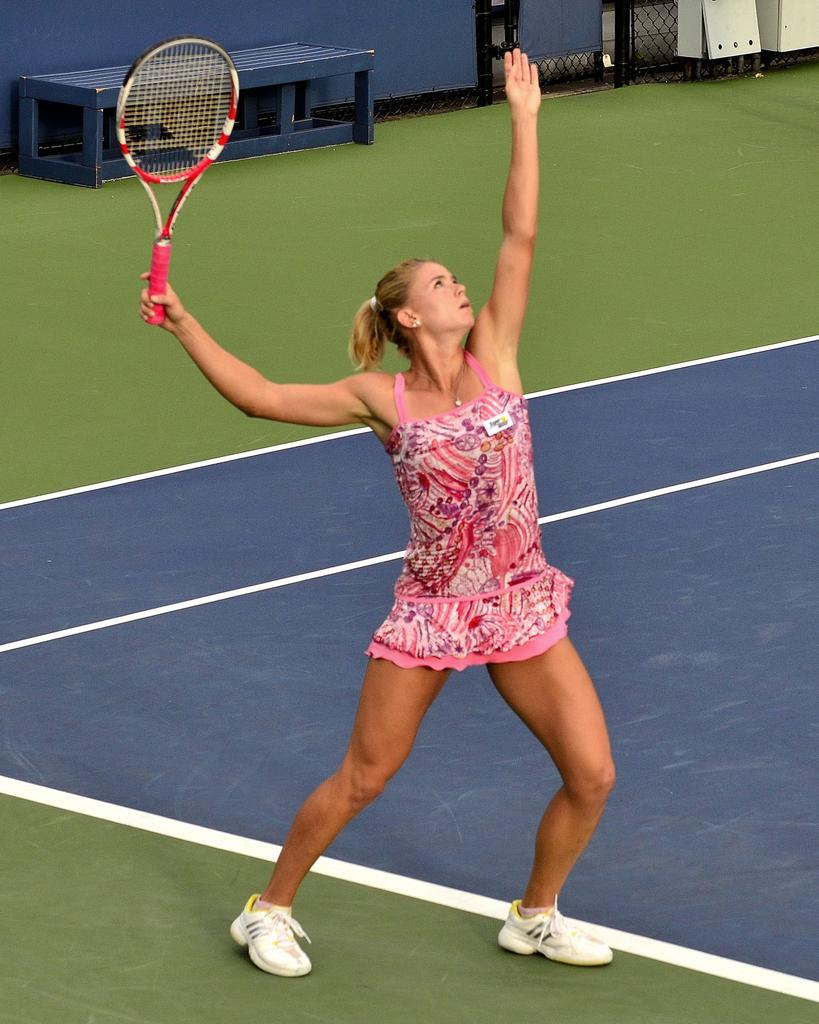Who is present in the image? There is a woman in the image. What is the woman holding in her hand? The woman is holding a bat in her hand. What can be seen in the background of the image? There is a bench in the background of the image. What type of toothbrush is the woman using in the image? There is no toothbrush present in the image; the woman is holding a bat. 